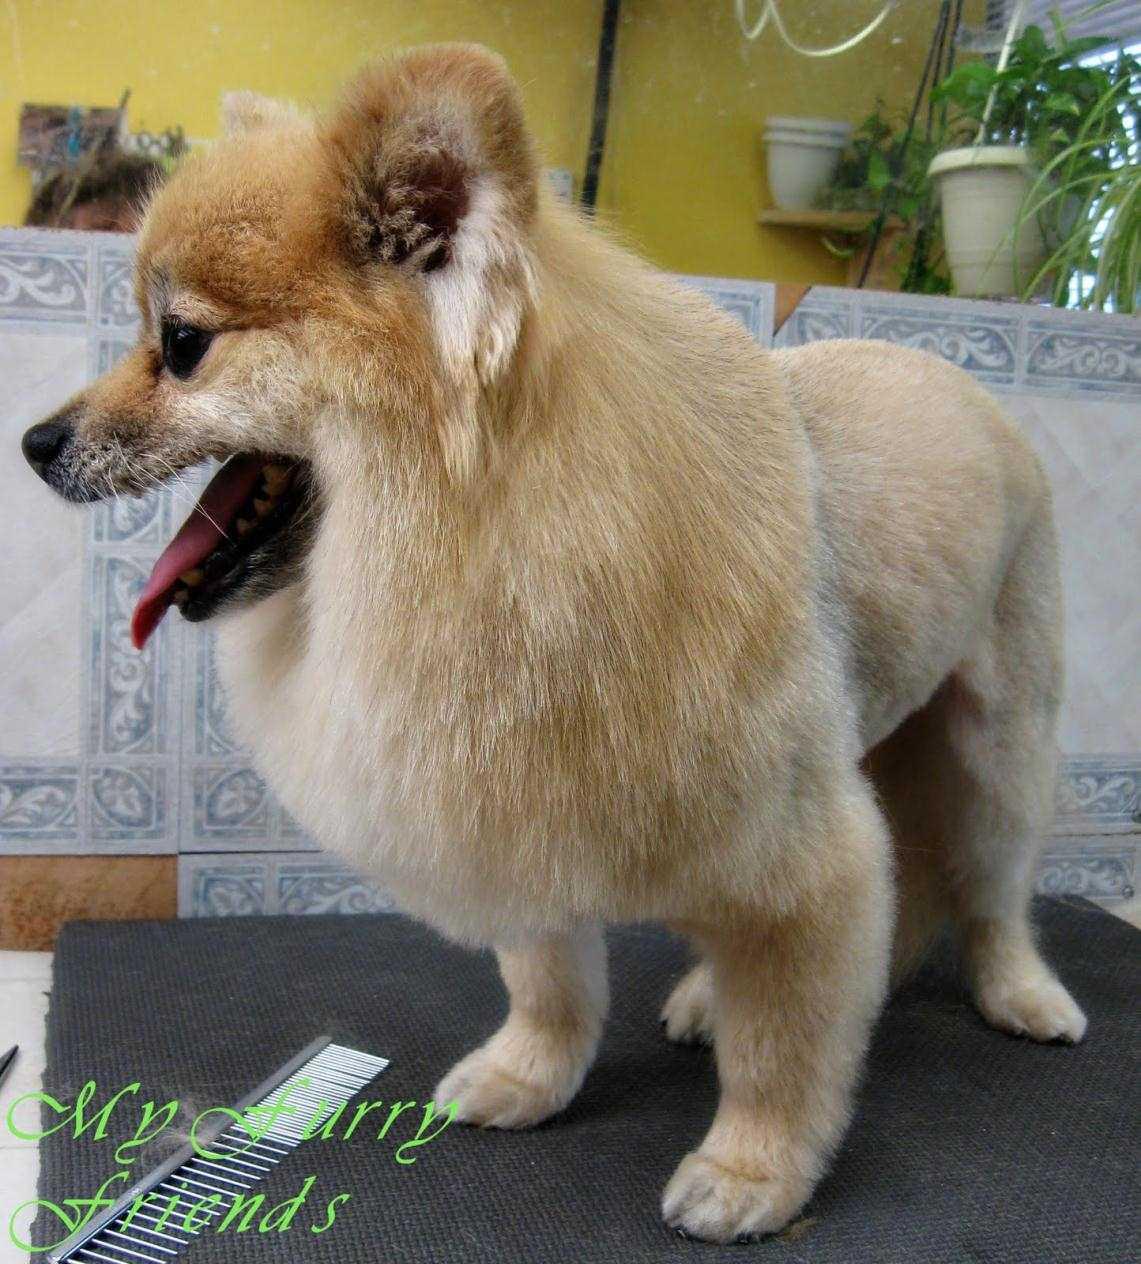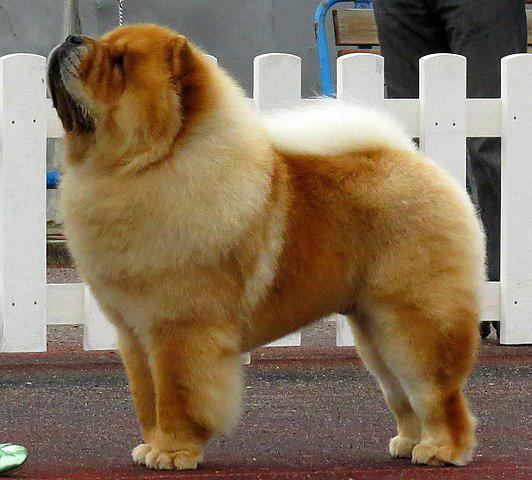The first image is the image on the left, the second image is the image on the right. For the images displayed, is the sentence "The dog in the right image is attached to a purple leash." factually correct? Answer yes or no. No. The first image is the image on the left, the second image is the image on the right. Analyze the images presented: Is the assertion "Right image shows a standing chow dog, and left image shows a different breed of dog standing." valid? Answer yes or no. Yes. 